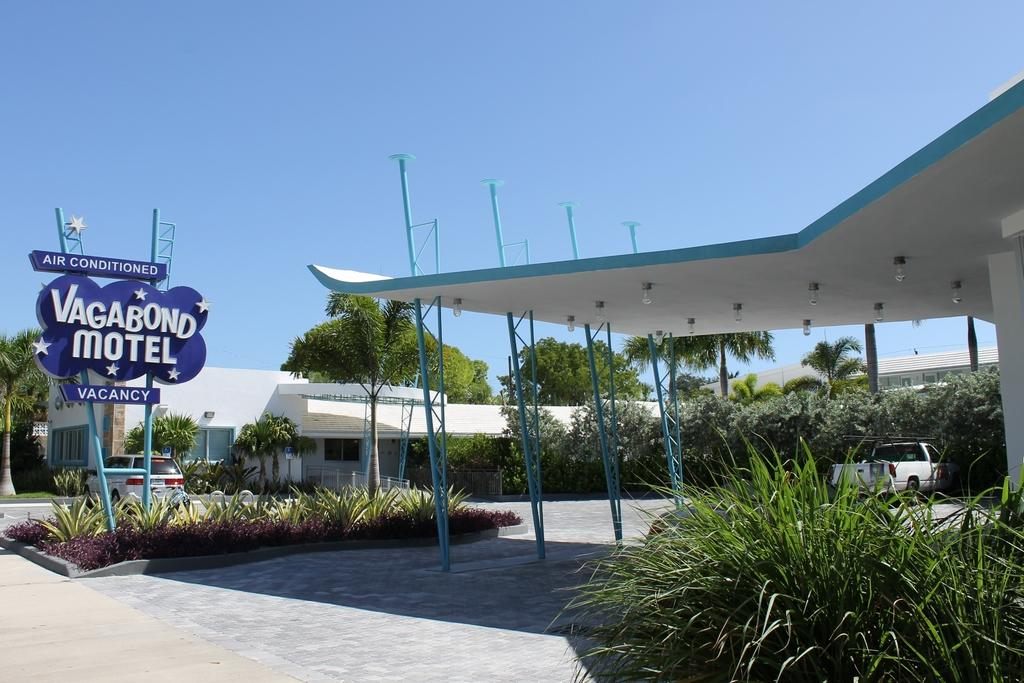<image>
Provide a brief description of the given image. The Vagabond Motel is a blue and white building that has air conditioning. 